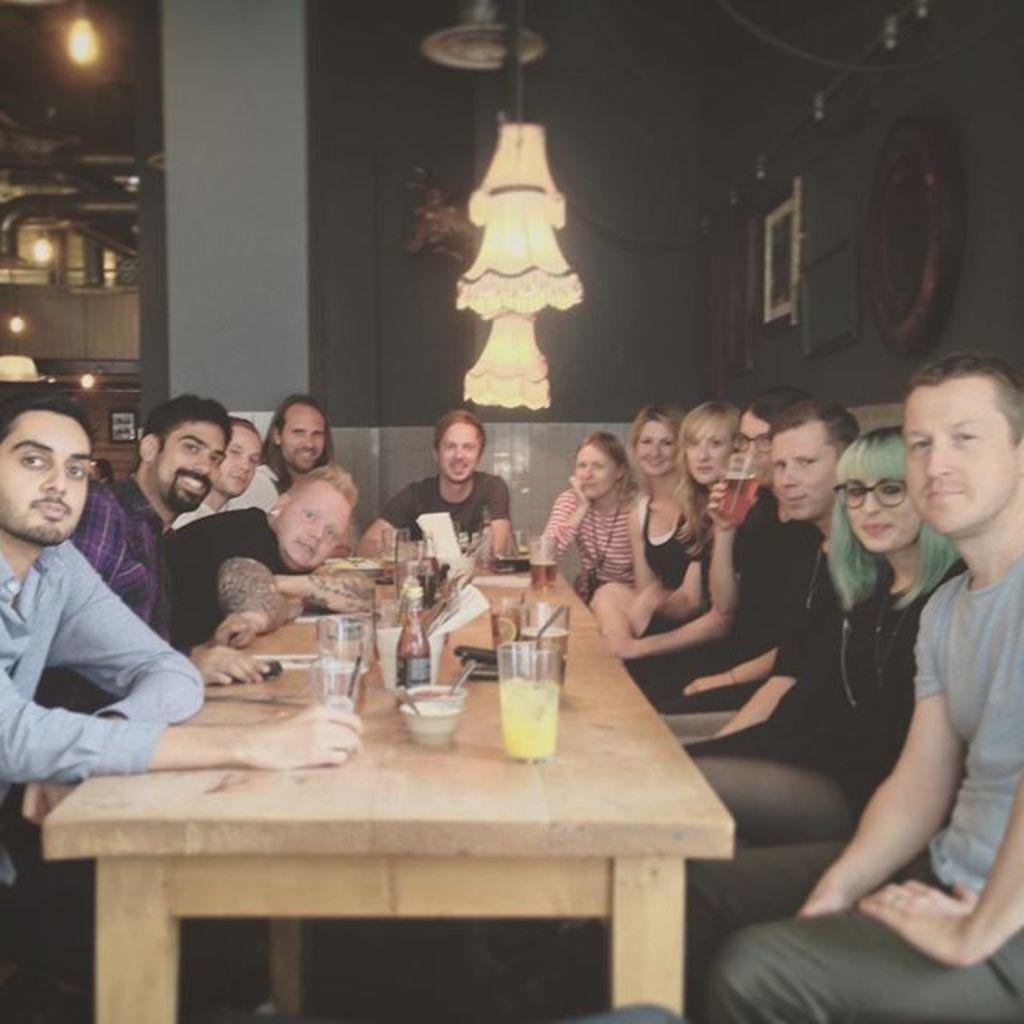Can you describe this image briefly? here in this picture we can see the persons sitting around the table in chair ,on the table we can see different different glasses,food items,bottles,tissue papers above the table we can see the lamp,here we can also see the wall clocks on the wall, different frames on the wall,here we can also see the light. 